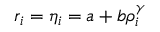Convert formula to latex. <formula><loc_0><loc_0><loc_500><loc_500>r _ { i } = \eta _ { i } = a + b \rho _ { i } ^ { \gamma }</formula> 